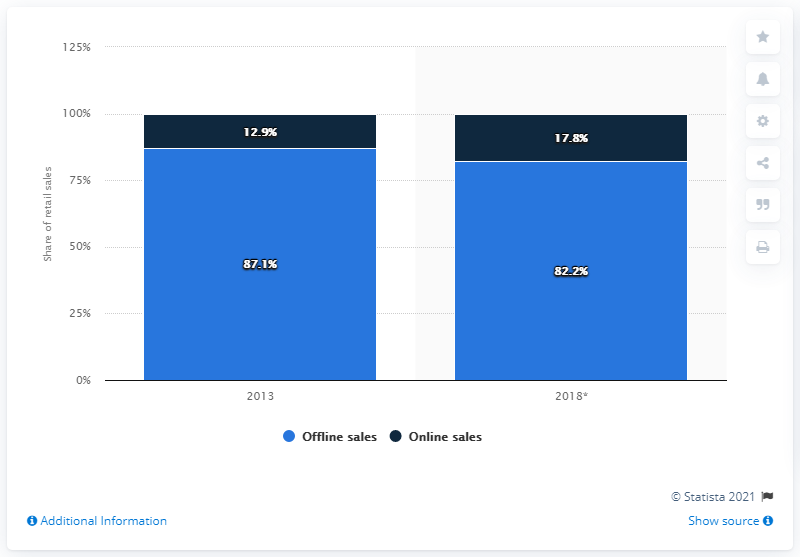Point out several critical features in this image. In the year 2013, online sales of clothing accounted for 12.9% of total retail sales of clothing. 